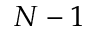Convert formula to latex. <formula><loc_0><loc_0><loc_500><loc_500>N - 1</formula> 